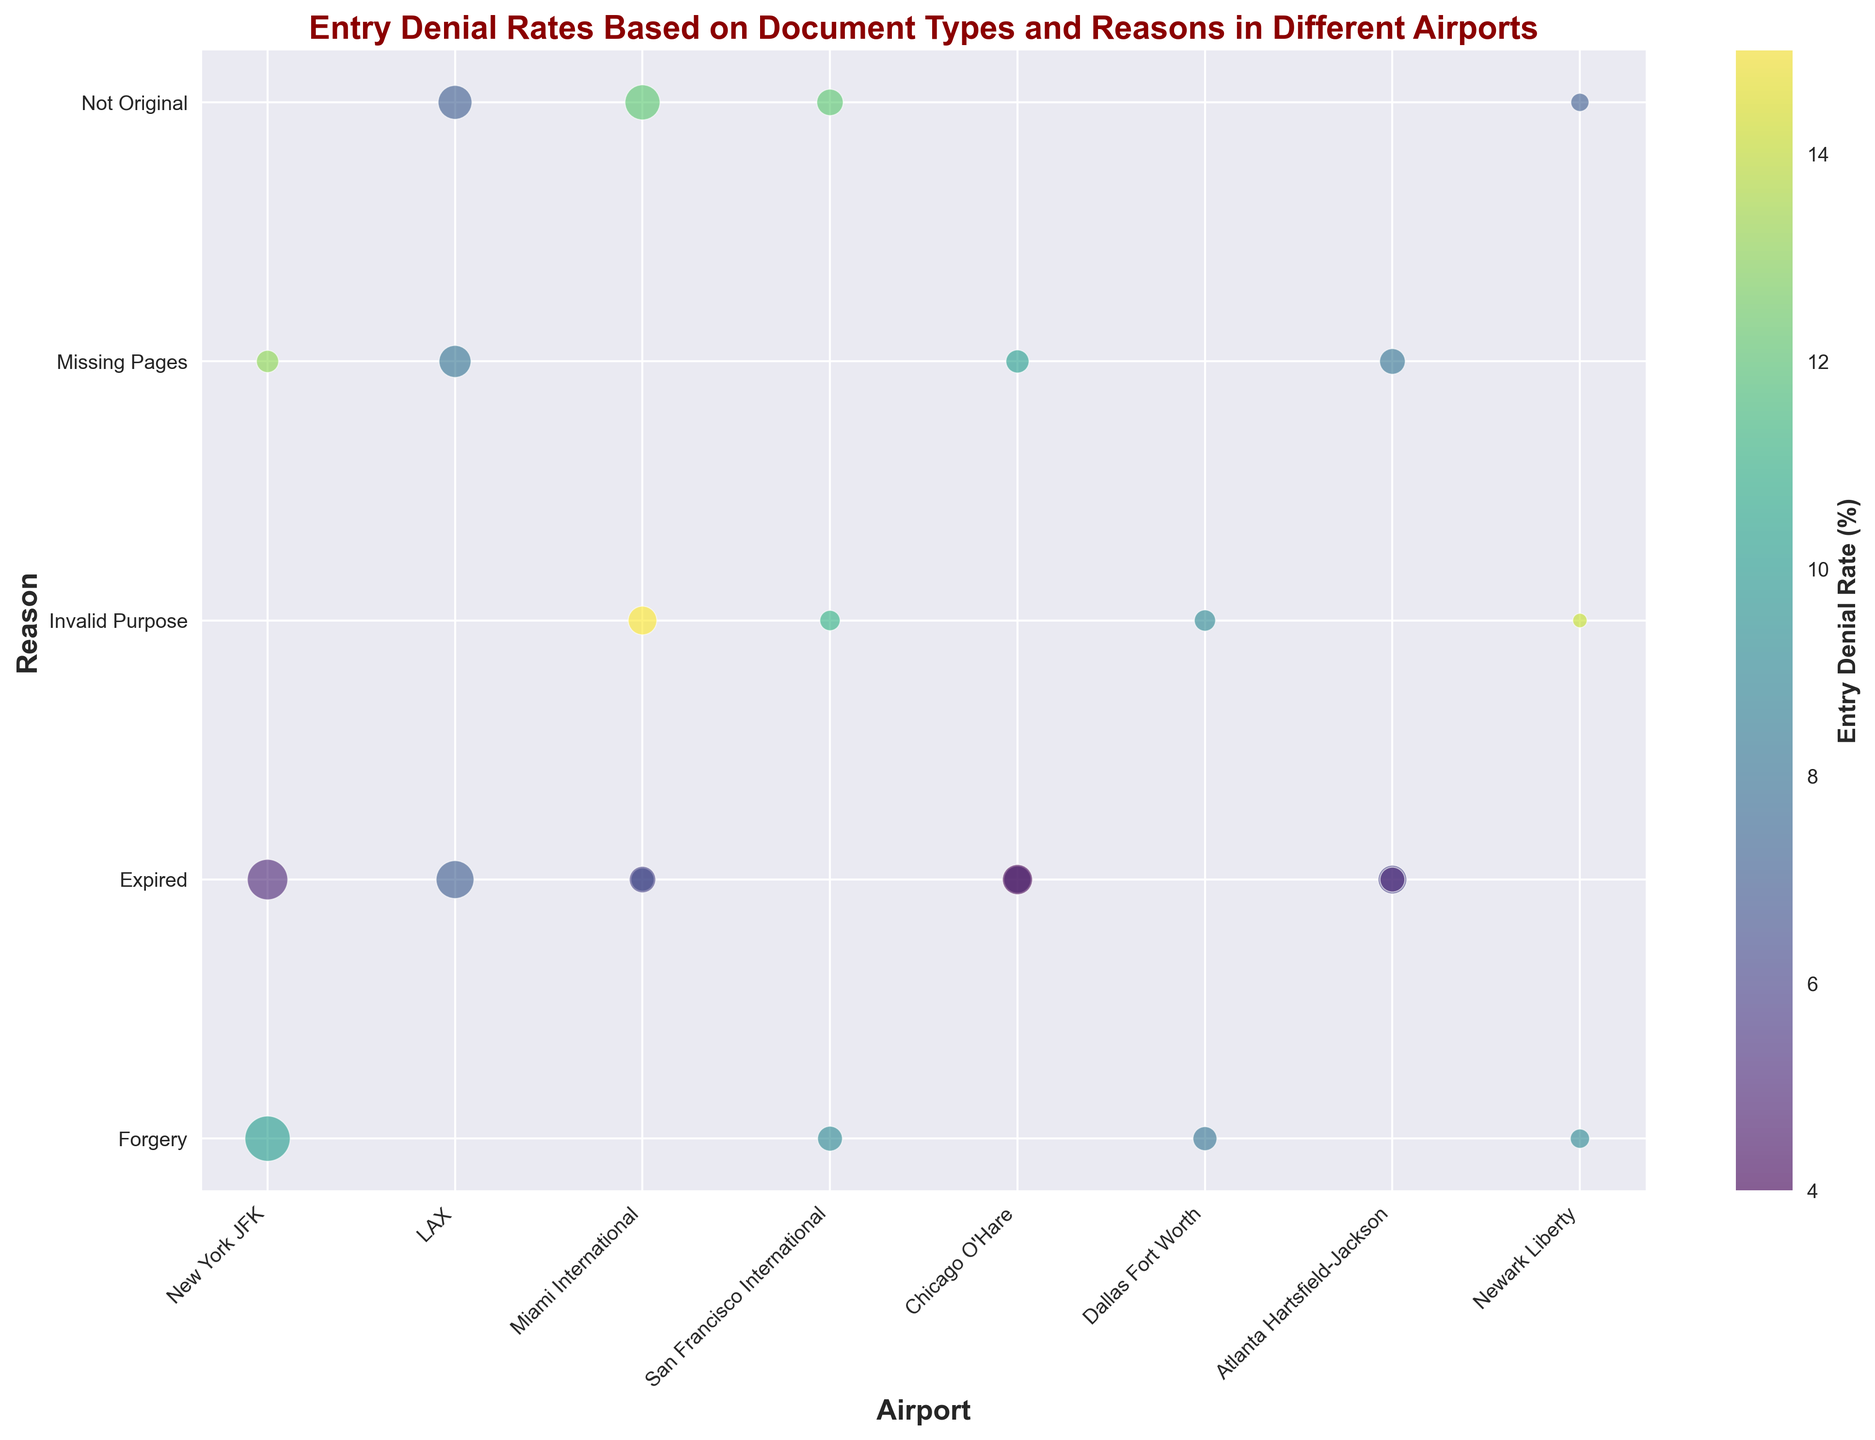How many reasons for entry denial have an Entry Denial Rate of 10% or higher? To find this, we look at the bubbles with an Entry Denial Rate of 10% or higher. We see that "Passport - Forgery" in New York JFK and Newark Liberty, "Visa - Invalid Purpose" in Miami International and Newark Liberty, "Travel Document - Not Original" in Miami International and San Francisco International, and "Travel Document - Missing Pages" in New York JFK have rates of at least 10%. This gives us a total of 7 reasons.
Answer: 7 Which reason for entry denial has the highest Entry Denial Rate in any airport? We need to identify the bubble with the darkest color, representing the highest percentage. It can be observed that "Visa - Invalid Purpose" at Newark Liberty has an Entry Denial Rate of 14%, which is the highest.
Answer: Visa - Invalid Purpose at Newark Liberty Compare the Entry Denial Rates for "Visa - Expired" at Miami International and Chicago O'Hare. Which airport has a higher rate? We can compare the two bubbles for "Visa - Expired" at Miami International and Chicago O’Hare. Miami International has an Entry Denial Rate of 6%, while Chicago O'Hare has a rate of 4%.
Answer: Miami International Which type of travel document has the highest count of entry denials due to "Missing Pages"? By identifying the bubble size corresponding to "Missing Pages" under each document type, we observe that the largest bubble for "Travel Document - Missing Pages" is in LAX. The count here is 25 for Travel Document.
Answer: Travel Document What is the combined Entry Denial Rate for "Passport - Expired" at LAX and "Passport - Expired" at Chicago O'Hare? Looking at the bubbles for "Passport - Expired" in both LAX and Chicago O'Hare, we add the Entry Denial Rates: 7% (LAX) and 6% (Chicago O'Hare). Thus, 7% + 6% = 13%.
Answer: 13% What is the most common reason for entry denials with Travel Documents? Checking the most frequently occurring reasons for "Travel Document" category, we see that "Not Original" appears more frequently across multiple airports compared to "Missing Pages".
Answer: Not Original For "Passport - Forgery," compare the Entry Denial Rates across all airports. Which airport has the lowest Entry Denial Rate? By examining the bubbles for "Passport - Forgery" across different airports, we see that the rates are 10% at New York JFK, 9% at San Francisco International, 8% at Dallas Fort Worth, and 9% at Newark Liberty. The lowest Entry Denial Rate is at Dallas Fort Worth with 8%.
Answer: Dallas Fort Worth How does the Entry Denial Rate for "Travel Document - Not Original" at Miami International compare to the rate at LAX? Identify the Entry Denial Rates for "Travel Document - Not Original" at both Miami International and LAX from the chart. Miami International has a rate of 12%, and LAX has a rate of 7%.
Answer: Miami International is higher What is the mean Entry Denial Rate for all reasons of "Visa" denials combined? The Entry Denial Rates for "Visa" denials are 15% (Miami International), 11% (San Francisco), 14% (Newark Liberty), and 9% (Dallas) for "Invalid Purpose", and 5% (NY JFK), 4% (Chicago O'Hare), 6% (Miami International), 5% (Atlanta Hartsfield) for "Expired". First, add these values: 15+11+14+9+5+4+6+5 = 69%. There are 8 entries so we divide by 8 to get the mean: 69 / 8 = 8.625%.
Answer: 8.625% 